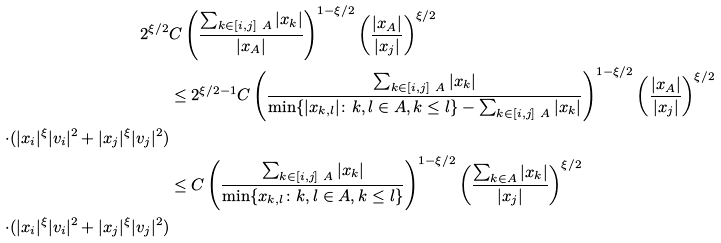<formula> <loc_0><loc_0><loc_500><loc_500>2 ^ { \xi / 2 } & C \left ( \frac { \sum _ { k \in [ i , j ] \ A } | x _ { k } | } { | x _ { A } | } \right ) ^ { 1 - \xi / 2 } \left ( \frac { | x _ { A } | } { | x _ { j } | } \right ) ^ { \xi / 2 } \\ & \leq 2 ^ { \xi / 2 - 1 } C \left ( \frac { \sum _ { k \in [ i , j ] \ A } | x _ { k } | } { \min \{ | x _ { k , l } | \colon k , l \in A , k \leq l \} - \sum _ { k \in [ i , j ] \ A } | x _ { k } | } \right ) ^ { 1 - \xi / 2 } \left ( \frac { | x _ { A } | } { | x _ { j } | } \right ) ^ { \xi / 2 } \\ \quad \cdot ( | x _ { i } | ^ { \xi } | v _ { i } | ^ { 2 } + | x _ { j } | ^ { \xi } | v _ { j } | ^ { 2 } ) \\ & \leq C \left ( \frac { \sum _ { k \in [ i , j ] \ A } | x _ { k } | } { \min \{ x _ { k , l } \colon k , l \in A , k \leq l \} } \right ) ^ { 1 - \xi / 2 } \left ( \frac { \sum _ { k \in A } | x _ { k } | } { | x _ { j } | } \right ) ^ { \xi / 2 } \\ \quad \cdot ( | x _ { i } | ^ { \xi } | v _ { i } | ^ { 2 } + | x _ { j } | ^ { \xi } | v _ { j } | ^ { 2 } )</formula> 